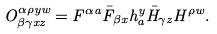<formula> <loc_0><loc_0><loc_500><loc_500>O ^ { \alpha \rho y w } _ { \beta \gamma x z } = F ^ { \alpha a } \bar { F } _ { \beta x } h ^ { y } _ { a } \bar { H } _ { \gamma z } H ^ { \rho w } .</formula> 